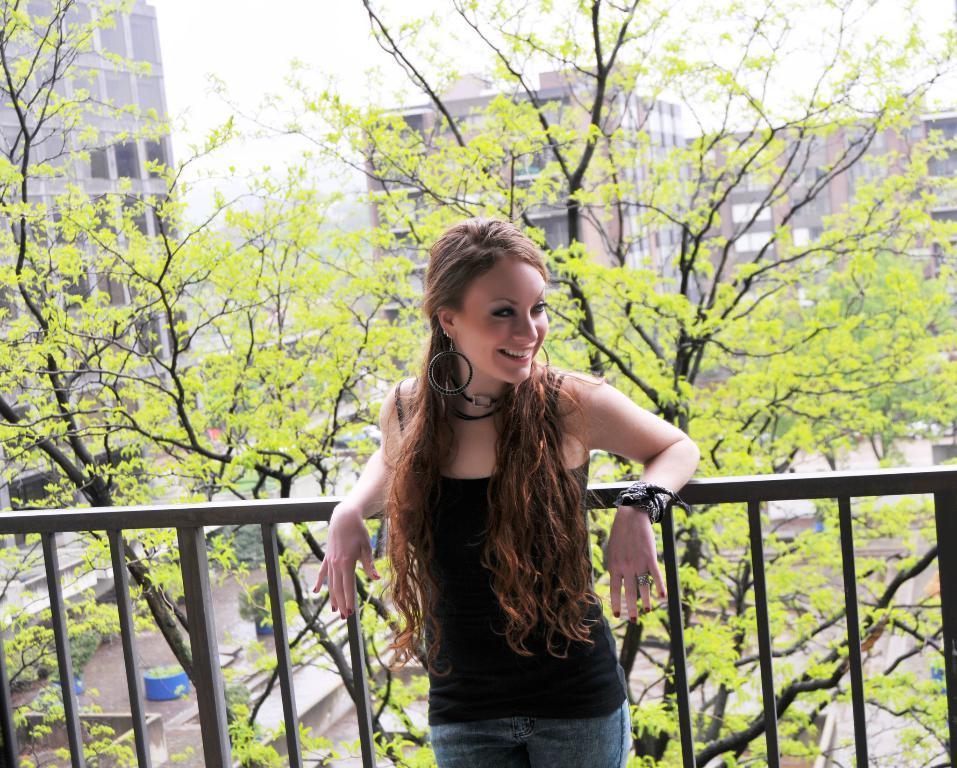Could you give a brief overview of what you see in this image? In this images we can see a girl is standing at the fence. In the background there are trees, buildings, plants in the pots and sky. 